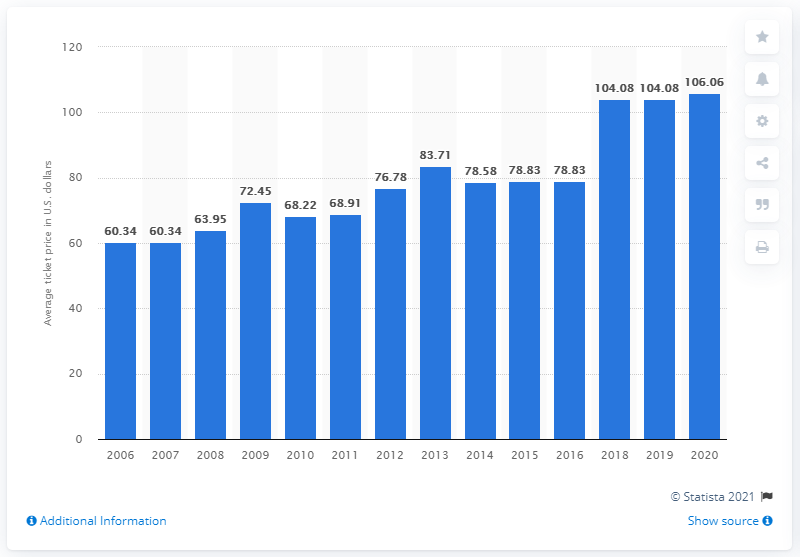List a handful of essential elements in this visual. The average ticket price for Atlanta Falcons games in 2020 was $106.06. 